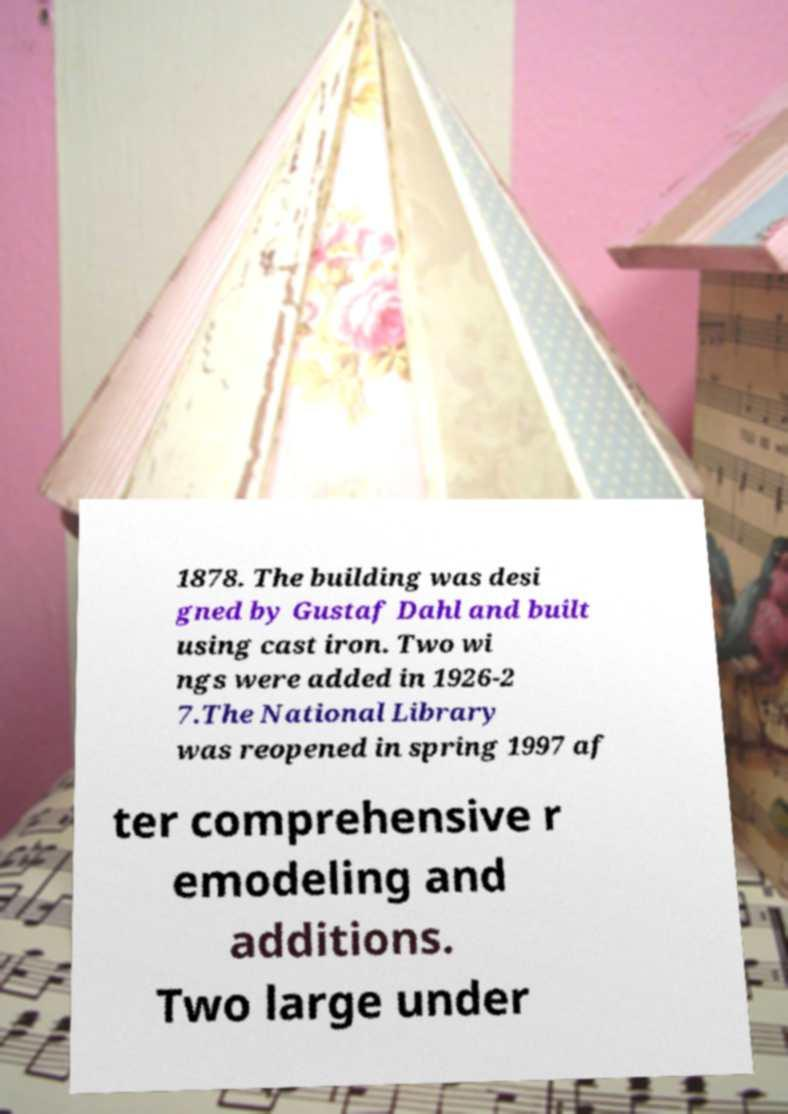I need the written content from this picture converted into text. Can you do that? 1878. The building was desi gned by Gustaf Dahl and built using cast iron. Two wi ngs were added in 1926-2 7.The National Library was reopened in spring 1997 af ter comprehensive r emodeling and additions. Two large under 